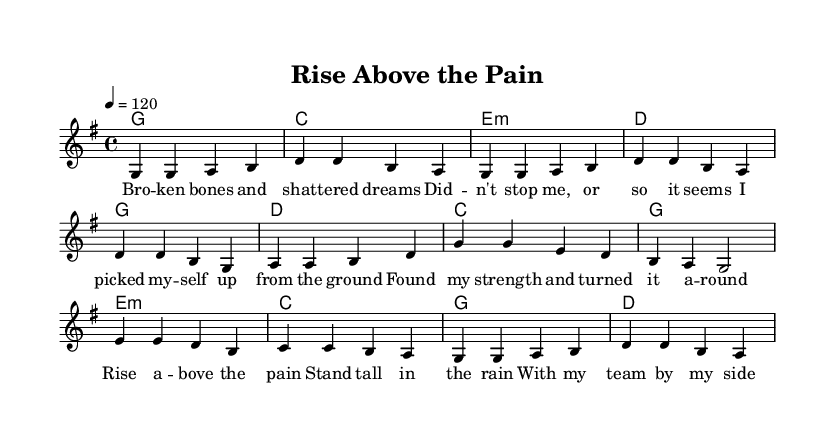What is the key signature of this music? The key signature can be found at the beginning of the sheet music, denoted by the sharp or flat symbols. Here, it shows no sharps or flats, which corresponds to G major.
Answer: G major What is the time signature of this music? The time signature appears at the beginning of the music, typically following the key signature. In this case, it is 4/4, meaning there are four beats per measure.
Answer: 4/4 What is the tempo of this music? The tempo marking is indicated in beats per minute (BPM). In this sheet music, it is marked as 120 beats per minute.
Answer: 120 Which section contains the lyrics about "broken bones"? This lyric is found in the verse section, where the lines "Bro -- ken bones and shat -- tered dreams" are written. The verse one is explicitly labeled in the sheet music.
Answer: Verse What is the main message conveyed in the chorus? The chorus includes the lyrics "Rise a -- bove the pain," which implies a theme of overcoming challenges, standing strong despite difficulties, and the importance of teamwork. A thorough reading of the chorus gives insight into its motivational themes.
Answer: Overcoming pain How many measures are in the bridge? To determine the number of measures in the bridge, count each measure presented between the introductory lines that introduce the bridge lyrics. The bridge consists of four measures as shown in the sheet music.
Answer: Four measures 